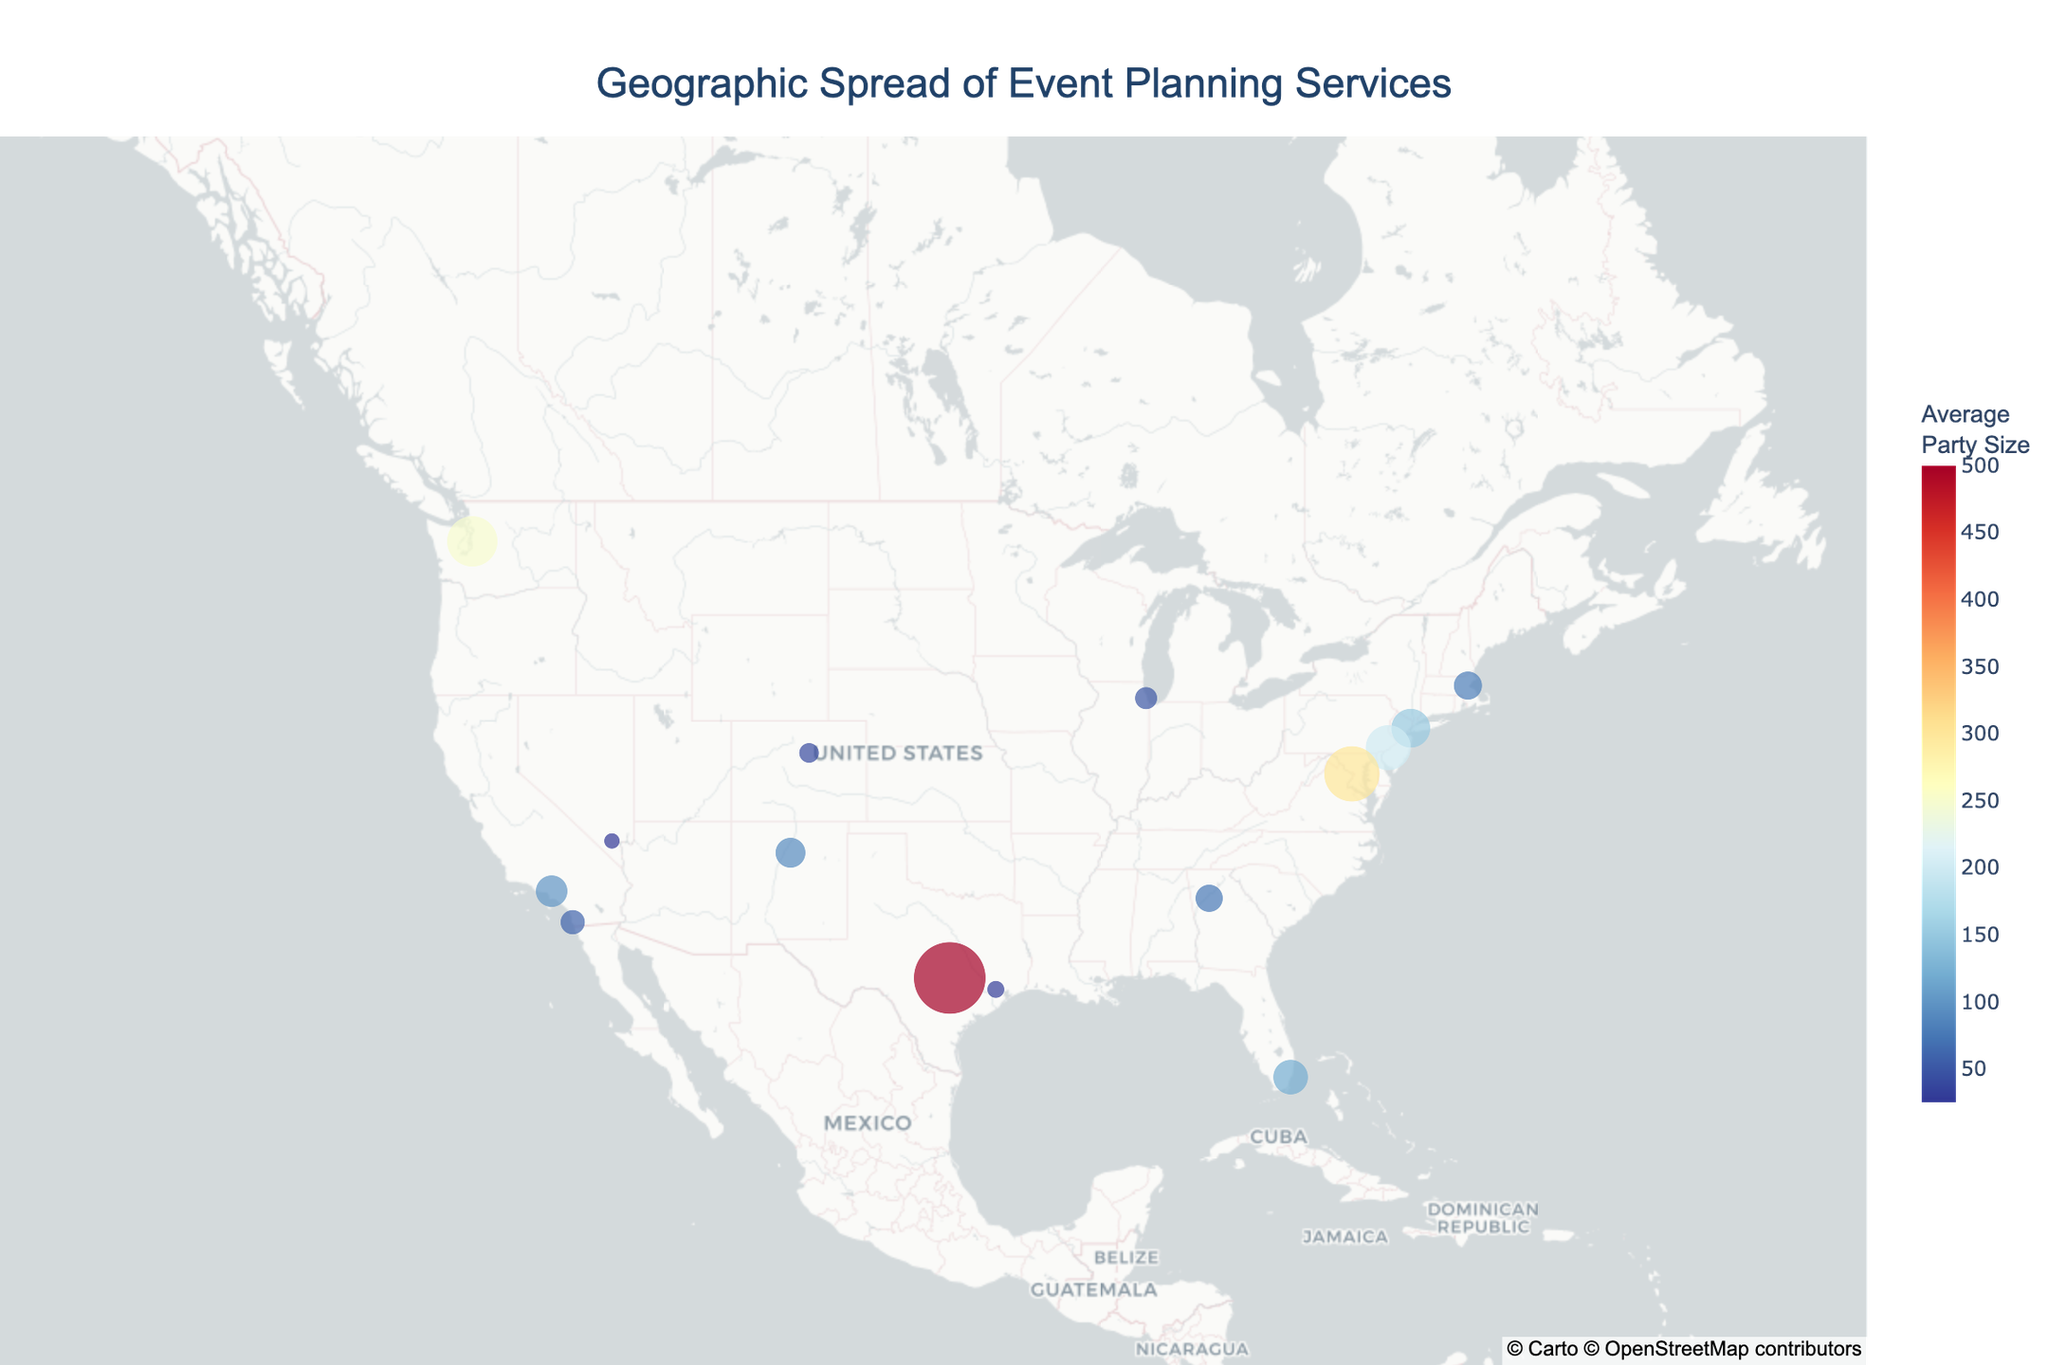Which city has the largest average party size? By looking at the size and color of the markers, we can see that Austin, TX has the largest marker, indicating it has the largest average party size.
Answer: Austin, TX What is the specialization of the event planning service in Seattle, WA? By examining the hover data for Seattle, WA, we can find that the specialization is Tech Company Launches.
Answer: Tech Company Launches How many cities have an average party size of 200 or more? By locating the markers with larger sizes and checking the hover data, we can identify Philadelphia, PA (200), Washington, D.C. (300), and Austin, TX (500).
Answer: 3 Which city focuses on political events? By hovering over the markers and checking the specialization, we find that Washington, D.C. focuses on Political Events.
Answer: Washington, D.C What is the average party size for event planning services in Los Angeles, CA? By looking at the hover data for Los Angeles, CA, we can see that the average party size is 100.
Answer: 100 Is the average party size in Boston, MA larger than in Atlanta, GA? By comparing the average party size shown in the hover data for Boston, MA (80) and Atlanta, GA (75), we can determine that Boston has a larger average party size.
Answer: Yes Which city specializes in Music Festivals and what is its average party size? By hovering over the markers and examining the hover data, we identify that Austin, TX specializes in Music Festivals with an average party size of 500.
Answer: Austin, TX; 500 Compare the average party size between New York, NY and Miami, FL. Which one is larger and by how much? The hover data shows New York, NY has an average party size of 150 and Miami, FL has 120. The difference is 150 - 120 = 30.
Answer: New York, NY; 30 What is the common feature of the color and size of the markers on the map? The color and size of the markers represent the average party size, with larger and darker colored markers indicating larger average party sizes.
Answer: Average party size 